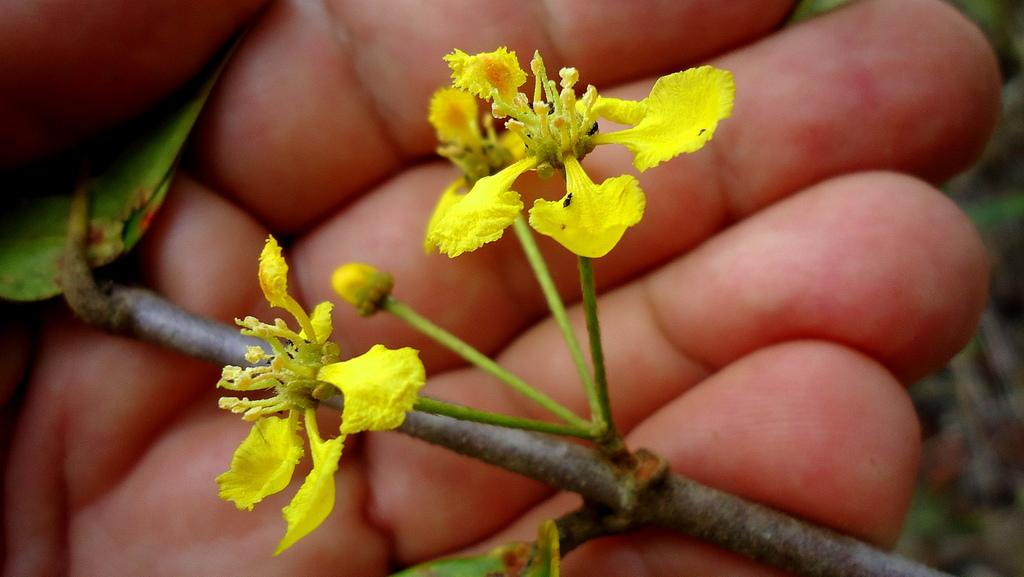What can be seen in the image? There is a person's hand in the image. What is the hand holding? The hand is holding the stem of a flower plant. What type of surprise is being revealed by the hand in the image? There is no indication of a surprise in the image; it simply shows a hand holding the stem of a flower plant. 